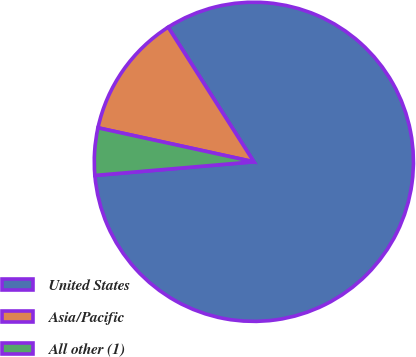Convert chart. <chart><loc_0><loc_0><loc_500><loc_500><pie_chart><fcel>United States<fcel>Asia/Pacific<fcel>All other (1)<nl><fcel>82.66%<fcel>12.56%<fcel>4.78%<nl></chart> 